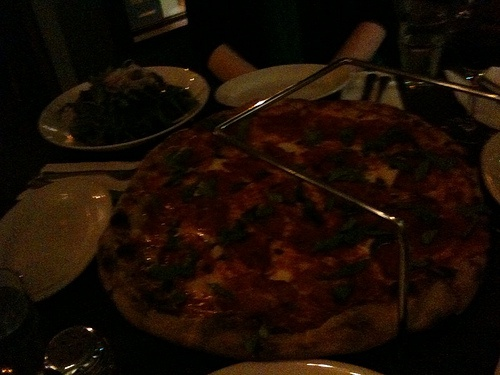Describe the objects in this image and their specific colors. I can see pizza in black, maroon, and brown tones, people in maroon and black tones, bowl in black, maroon, and gray tones, bowl in maroon and black tones, and cup in black and gray tones in this image. 